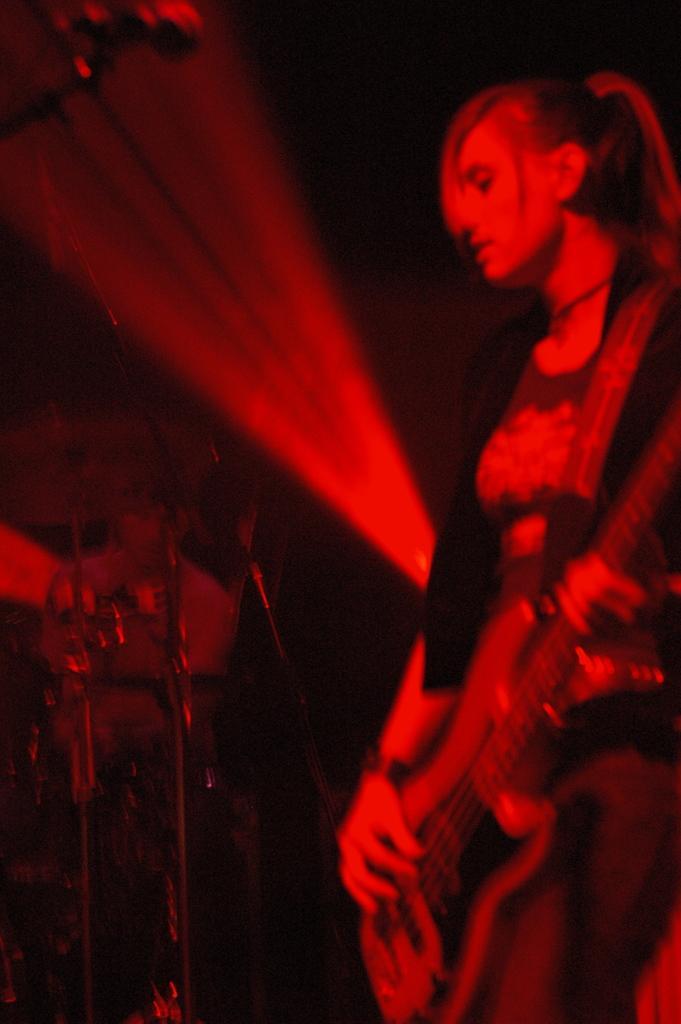What is the woman in the image holding? The woman is holding a guitar. What is the woman doing with the guitar? The woman is playing the guitar. Can you describe the background of the image? There is a person and a drum in the background of the image. What is the color scheme of the image? The image has a predominantly red and black color scheme. What type of cream is the woman using to play the guitar in the image? There is no cream present in the image, and the woman is playing the guitar without any cream. Can you see any worms crawling on the guitar in the image? There are no worms present in the image; the guitar is being played by the woman without any worms. 